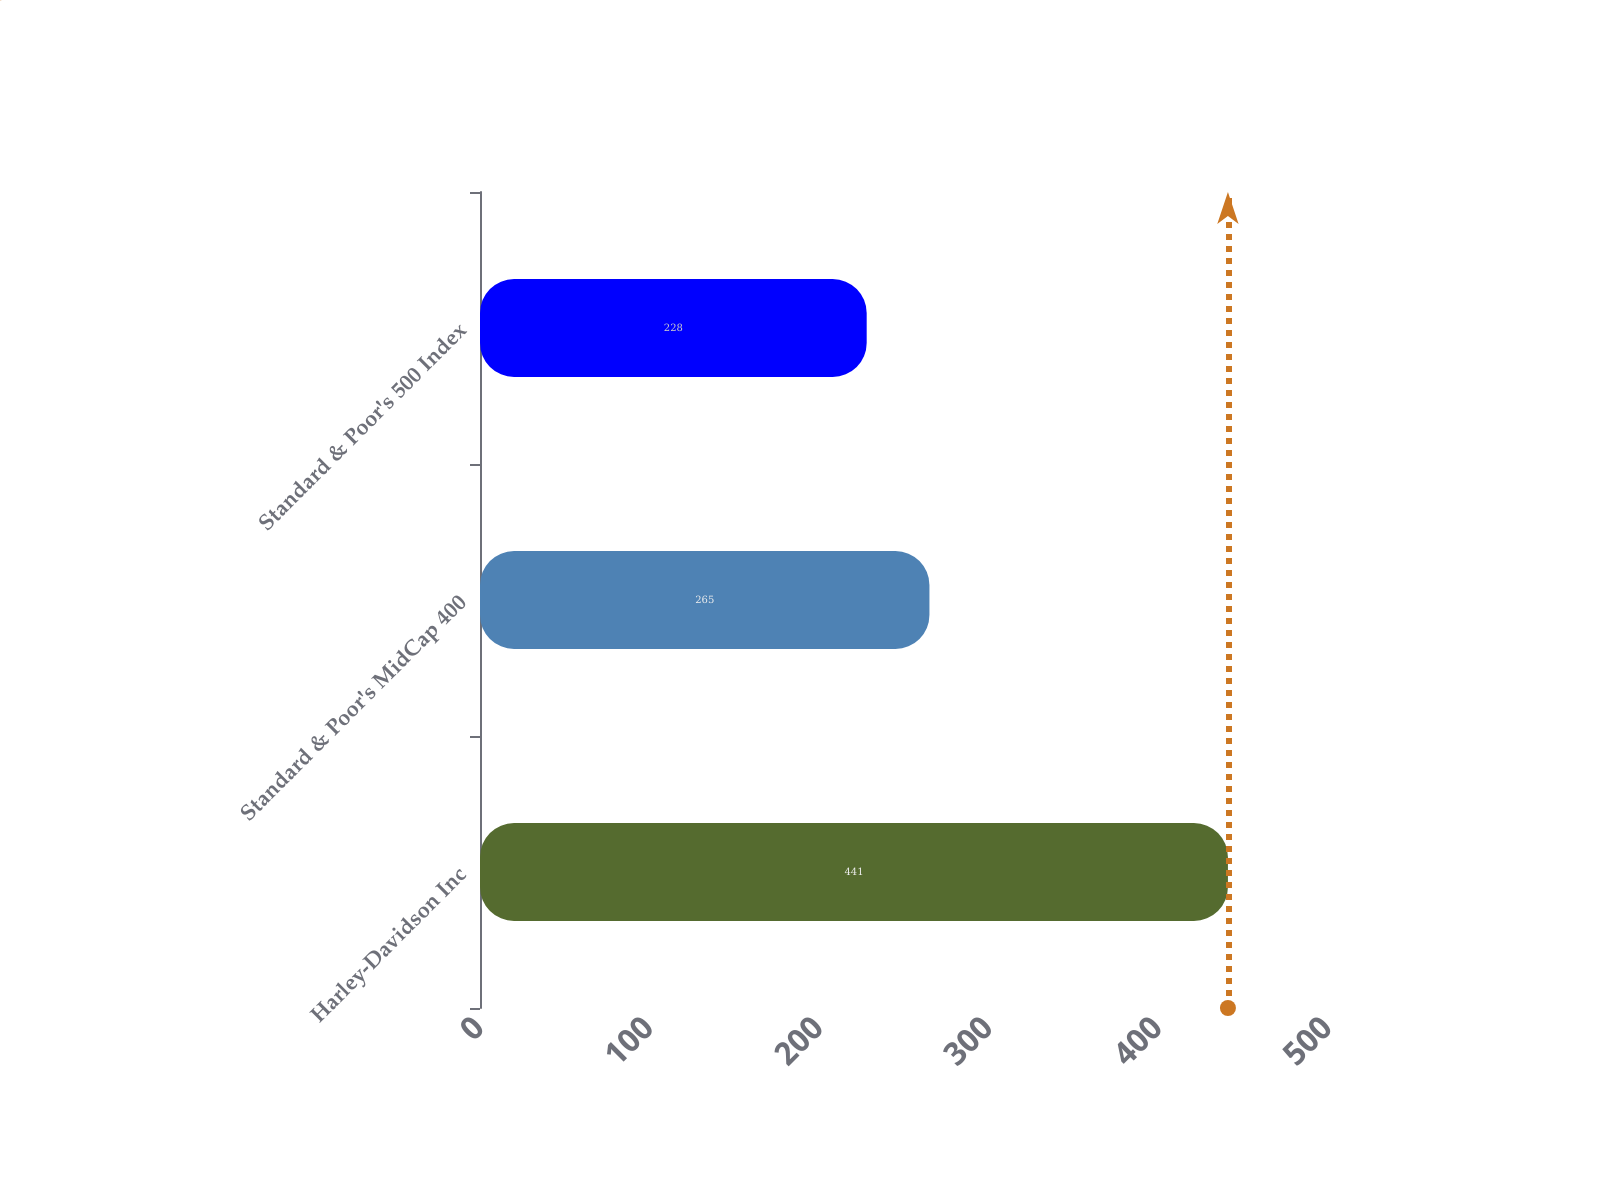Convert chart. <chart><loc_0><loc_0><loc_500><loc_500><bar_chart><fcel>Harley-Davidson Inc<fcel>Standard & Poor's MidCap 400<fcel>Standard & Poor's 500 Index<nl><fcel>441<fcel>265<fcel>228<nl></chart> 